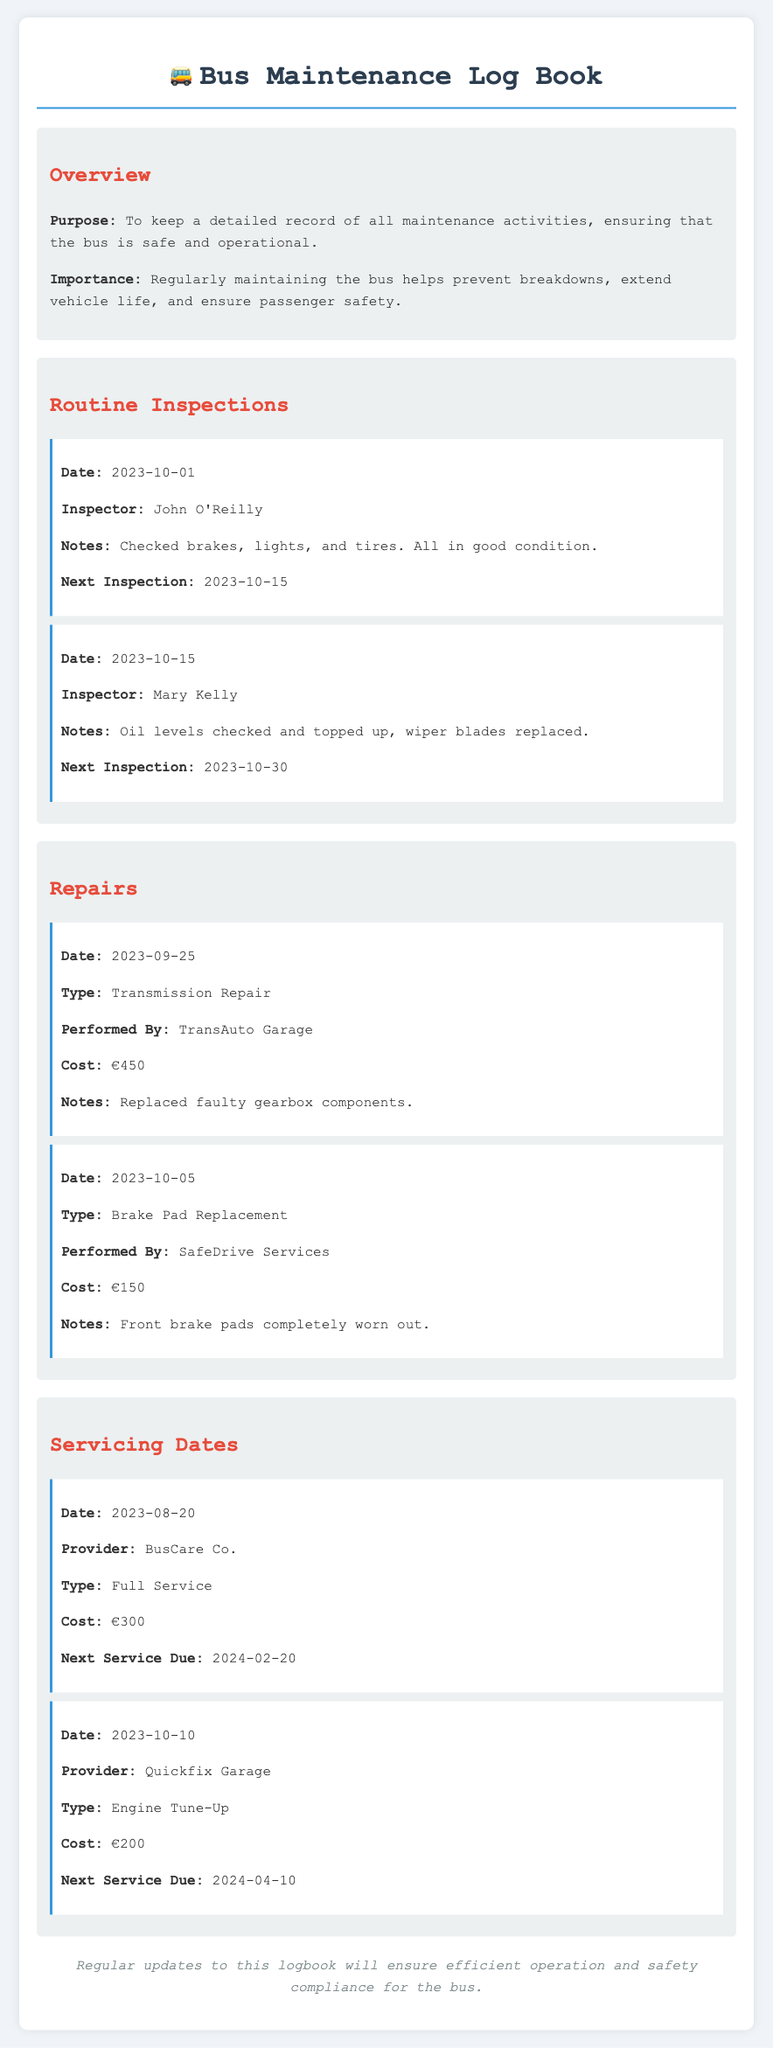what is the purpose of the maintenance log book? The purpose is to keep a detailed record of all maintenance activities, ensuring that the bus is safe and operational.
Answer: to keep a detailed record of all maintenance activities who inspected the bus on October 1, 2023? The inspector who checked the bus on this date is John O'Reilly.
Answer: John O'Reilly what type of repair was performed on September 25, 2023? The repair performed on this date was a transmission repair.
Answer: Transmission Repair what is the cost for the engine tune-up service? The cost for the engine tune-up service done on October 10, 2023, is €200.
Answer: €200 when is the next routine inspection after October 15, 2023? The next routine inspection after this date is scheduled for October 30, 2023.
Answer: 2023-10-30 how much did the full service cost? The full service cost was €300.
Answer: €300 what was noted during the inspection on October 15, 2023? It was noted that oil levels were checked and topped up, and wiper blades were replaced.
Answer: Oil levels checked and topped up, wiper blades replaced which provider performed the full service on August 20, 2023? The provider that performed the full service on this date is BusCare Co.
Answer: BusCare Co what is the next service due after the engine tune-up? The next service due after the engine tune-up is April 10, 2024.
Answer: 2024-04-10 